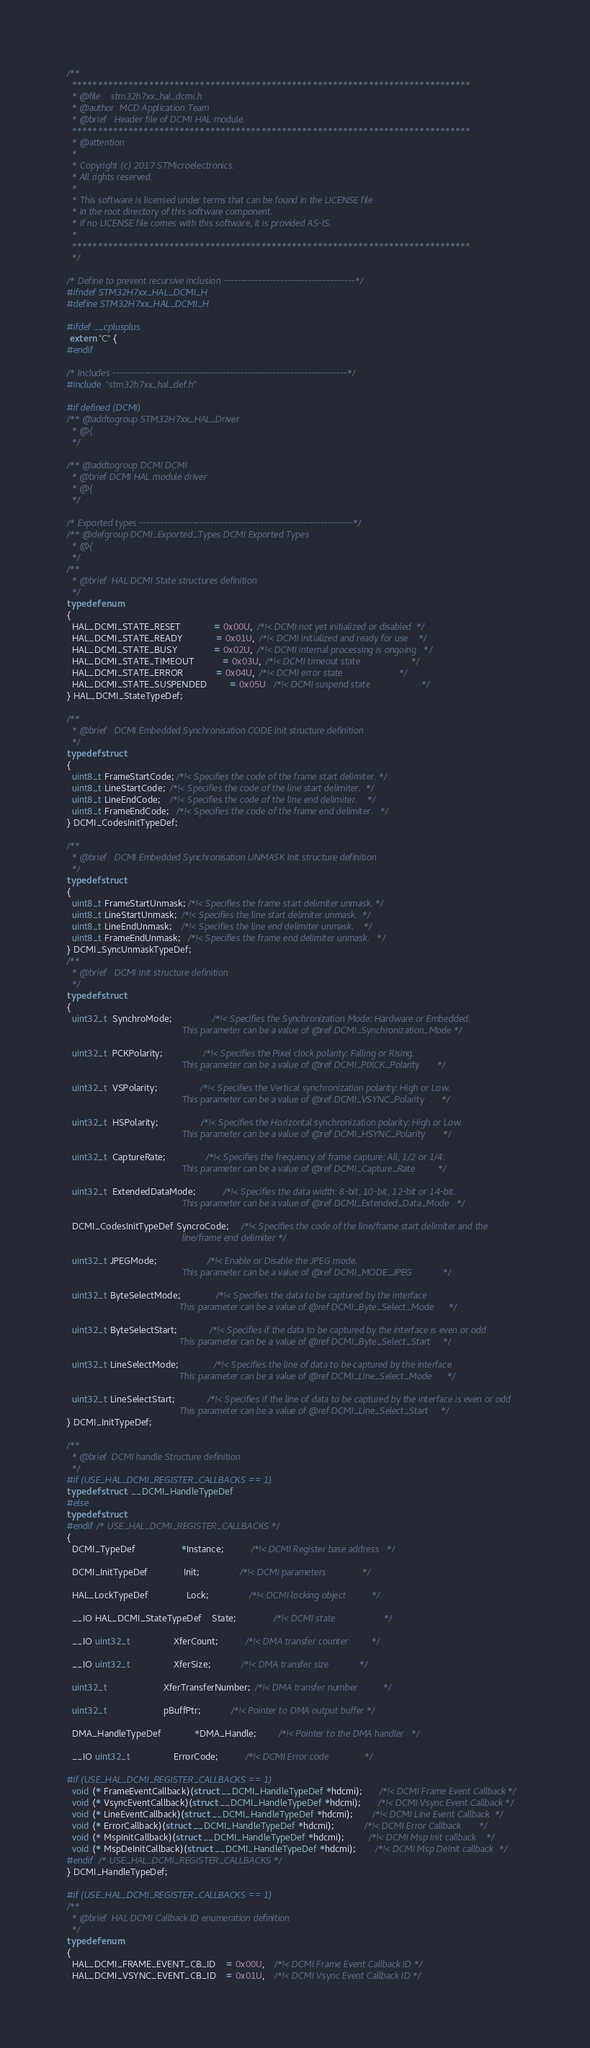<code> <loc_0><loc_0><loc_500><loc_500><_C_>/**
  ******************************************************************************
  * @file    stm32h7xx_hal_dcmi.h
  * @author  MCD Application Team
  * @brief   Header file of DCMI HAL module.
  ******************************************************************************
  * @attention
  *
  * Copyright (c) 2017 STMicroelectronics.
  * All rights reserved.
  *
  * This software is licensed under terms that can be found in the LICENSE file
  * in the root directory of this software component.
  * If no LICENSE file comes with this software, it is provided AS-IS.
  *
  ******************************************************************************
  */

/* Define to prevent recursive inclusion -------------------------------------*/
#ifndef STM32H7xx_HAL_DCMI_H
#define STM32H7xx_HAL_DCMI_H

#ifdef __cplusplus
 extern "C" {
#endif

/* Includes ------------------------------------------------------------------*/
#include "stm32h7xx_hal_def.h"

#if defined (DCMI)
/** @addtogroup STM32H7xx_HAL_Driver
  * @{
  */

/** @addtogroup DCMI DCMI
  * @brief DCMI HAL module driver
  * @{
  */

/* Exported types ------------------------------------------------------------*/
/** @defgroup DCMI_Exported_Types DCMI Exported Types
  * @{
  */
/**
  * @brief  HAL DCMI State structures definition
  */
typedef enum
{
  HAL_DCMI_STATE_RESET             = 0x00U,  /*!< DCMI not yet initialized or disabled  */
  HAL_DCMI_STATE_READY             = 0x01U,  /*!< DCMI initialized and ready for use    */
  HAL_DCMI_STATE_BUSY              = 0x02U,  /*!< DCMI internal processing is ongoing   */
  HAL_DCMI_STATE_TIMEOUT           = 0x03U,  /*!< DCMI timeout state                    */
  HAL_DCMI_STATE_ERROR             = 0x04U,  /*!< DCMI error state                      */
  HAL_DCMI_STATE_SUSPENDED         = 0x05U   /*!< DCMI suspend state                    */
} HAL_DCMI_StateTypeDef;

/**
  * @brief   DCMI Embedded Synchronisation CODE Init structure definition
  */
typedef struct
{
  uint8_t FrameStartCode; /*!< Specifies the code of the frame start delimiter. */
  uint8_t LineStartCode;  /*!< Specifies the code of the line start delimiter.  */
  uint8_t LineEndCode;    /*!< Specifies the code of the line end delimiter.    */
  uint8_t FrameEndCode;   /*!< Specifies the code of the frame end delimiter.   */
} DCMI_CodesInitTypeDef;

/**
  * @brief   DCMI Embedded Synchronisation UNMASK Init structure definition
  */
typedef struct
{
  uint8_t FrameStartUnmask; /*!< Specifies the frame start delimiter unmask. */
  uint8_t LineStartUnmask;  /*!< Specifies the line start delimiter unmask.  */
  uint8_t LineEndUnmask;    /*!< Specifies the line end delimiter unmask.    */
  uint8_t FrameEndUnmask;   /*!< Specifies the frame end delimiter unmask.   */
} DCMI_SyncUnmaskTypeDef;
/**
  * @brief   DCMI Init structure definition
  */
typedef struct
{
  uint32_t  SynchroMode;                /*!< Specifies the Synchronization Mode: Hardware or Embedded.
                                             This parameter can be a value of @ref DCMI_Synchronization_Mode */

  uint32_t  PCKPolarity;                /*!< Specifies the Pixel clock polarity: Falling or Rising.
                                             This parameter can be a value of @ref DCMI_PIXCK_Polarity       */

  uint32_t  VSPolarity;                 /*!< Specifies the Vertical synchronization polarity: High or Low.
                                             This parameter can be a value of @ref DCMI_VSYNC_Polarity       */

  uint32_t  HSPolarity;                 /*!< Specifies the Horizontal synchronization polarity: High or Low.
                                             This parameter can be a value of @ref DCMI_HSYNC_Polarity       */

  uint32_t  CaptureRate;                /*!< Specifies the frequency of frame capture: All, 1/2 or 1/4.
                                             This parameter can be a value of @ref DCMI_Capture_Rate         */

  uint32_t  ExtendedDataMode;           /*!< Specifies the data width: 8-bit, 10-bit, 12-bit or 14-bit.
                                             This parameter can be a value of @ref DCMI_Extended_Data_Mode   */

  DCMI_CodesInitTypeDef SyncroCode;     /*!< Specifies the code of the line/frame start delimiter and the
                                             line/frame end delimiter */

  uint32_t JPEGMode;                    /*!< Enable or Disable the JPEG mode.
                                             This parameter can be a value of @ref DCMI_MODE_JPEG            */

  uint32_t ByteSelectMode;              /*!< Specifies the data to be captured by the interface
                                            This parameter can be a value of @ref DCMI_Byte_Select_Mode      */

  uint32_t ByteSelectStart;             /*!< Specifies if the data to be captured by the interface is even or odd
                                            This parameter can be a value of @ref DCMI_Byte_Select_Start     */

  uint32_t LineSelectMode;              /*!< Specifies the line of data to be captured by the interface
                                            This parameter can be a value of @ref DCMI_Line_Select_Mode      */

  uint32_t LineSelectStart;             /*!< Specifies if the line of data to be captured by the interface is even or odd
                                            This parameter can be a value of @ref DCMI_Line_Select_Start     */
} DCMI_InitTypeDef;

/**
  * @brief  DCMI handle Structure definition
  */
#if (USE_HAL_DCMI_REGISTER_CALLBACKS == 1)
typedef struct  __DCMI_HandleTypeDef
#else
typedef struct
#endif /* USE_HAL_DCMI_REGISTER_CALLBACKS */
{
  DCMI_TypeDef                  *Instance;           /*!< DCMI Register base address   */

  DCMI_InitTypeDef              Init;                /*!< DCMI parameters              */

  HAL_LockTypeDef               Lock;                /*!< DCMI locking object          */

  __IO HAL_DCMI_StateTypeDef    State;               /*!< DCMI state                   */

  __IO uint32_t                 XferCount;           /*!< DMA transfer counter         */

  __IO uint32_t                 XferSize;            /*!< DMA transfer size            */

  uint32_t                      XferTransferNumber;  /*!< DMA transfer number          */

  uint32_t                      pBuffPtr;            /*!< Pointer to DMA output buffer */

  DMA_HandleTypeDef             *DMA_Handle;         /*!< Pointer to the DMA handler   */

  __IO uint32_t                 ErrorCode;           /*!< DCMI Error code              */

#if (USE_HAL_DCMI_REGISTER_CALLBACKS == 1)
  void (* FrameEventCallback)(struct __DCMI_HandleTypeDef *hdcmi);       /*!< DCMI Frame Event Callback */
  void (* VsyncEventCallback)(struct __DCMI_HandleTypeDef *hdcmi);       /*!< DCMI Vsync Event Callback */
  void (* LineEventCallback)(struct __DCMI_HandleTypeDef *hdcmi);        /*!< DCMI Line Event Callback  */
  void (* ErrorCallback)(struct __DCMI_HandleTypeDef *hdcmi);            /*!< DCMI Error Callback       */
  void (* MspInitCallback)(struct __DCMI_HandleTypeDef *hdcmi);          /*!< DCMI Msp Init callback    */
  void (* MspDeInitCallback)(struct __DCMI_HandleTypeDef *hdcmi);        /*!< DCMI Msp DeInit callback  */
#endif  /* USE_HAL_DCMI_REGISTER_CALLBACKS */
} DCMI_HandleTypeDef;

#if (USE_HAL_DCMI_REGISTER_CALLBACKS == 1)
/**
  * @brief  HAL DCMI Callback ID enumeration definition
  */
typedef enum
{
  HAL_DCMI_FRAME_EVENT_CB_ID    = 0x00U,    /*!< DCMI Frame Event Callback ID */
  HAL_DCMI_VSYNC_EVENT_CB_ID    = 0x01U,    /*!< DCMI Vsync Event Callback ID */</code> 